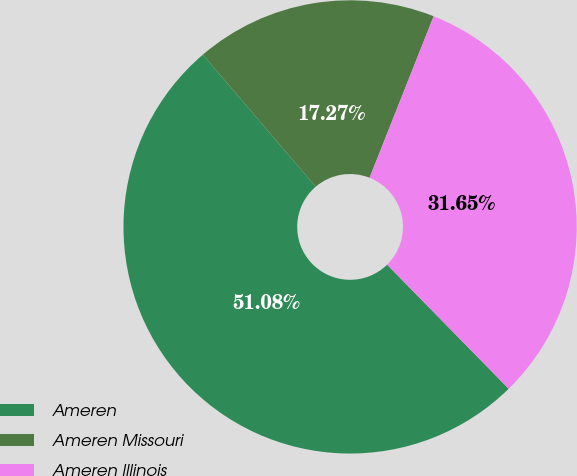Convert chart to OTSL. <chart><loc_0><loc_0><loc_500><loc_500><pie_chart><fcel>Ameren<fcel>Ameren Missouri<fcel>Ameren Illinois<nl><fcel>51.08%<fcel>17.27%<fcel>31.65%<nl></chart> 